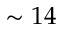Convert formula to latex. <formula><loc_0><loc_0><loc_500><loc_500>\sim 1 4</formula> 